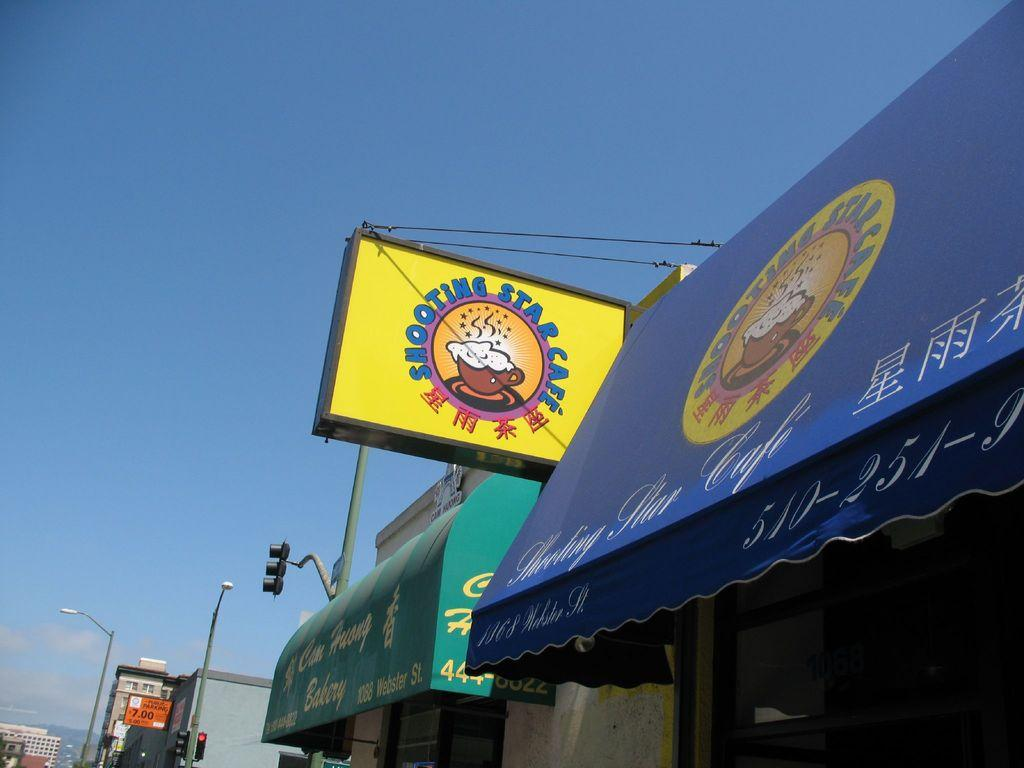<image>
Present a compact description of the photo's key features. Chinese restaurant that is called the shooting star cafe 